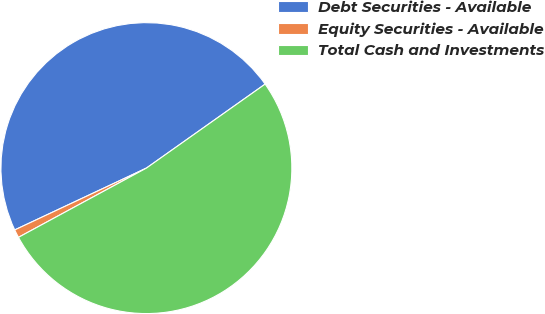Convert chart. <chart><loc_0><loc_0><loc_500><loc_500><pie_chart><fcel>Debt Securities - Available<fcel>Equity Securities - Available<fcel>Total Cash and Investments<nl><fcel>47.19%<fcel>0.91%<fcel>51.91%<nl></chart> 